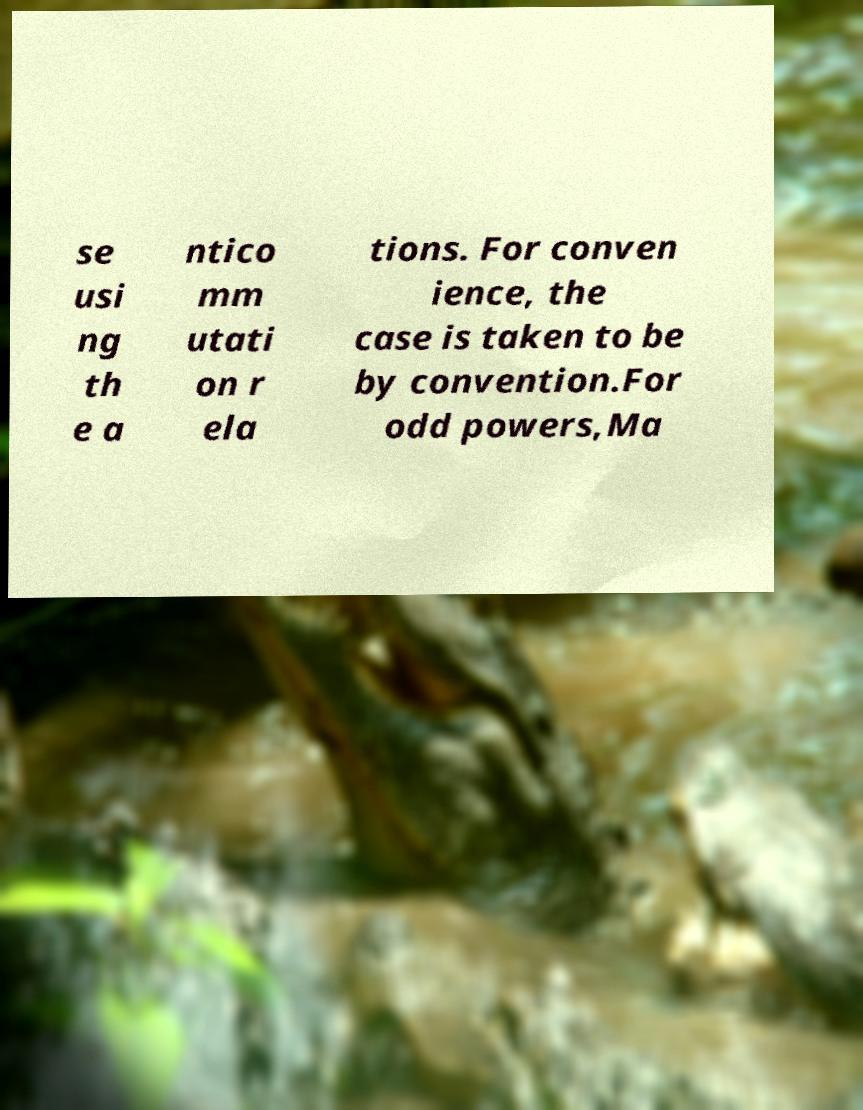There's text embedded in this image that I need extracted. Can you transcribe it verbatim? se usi ng th e a ntico mm utati on r ela tions. For conven ience, the case is taken to be by convention.For odd powers,Ma 